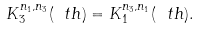Convert formula to latex. <formula><loc_0><loc_0><loc_500><loc_500>K _ { 3 } ^ { n _ { 1 } , n _ { 3 } } ( \ t h ) = K _ { 1 } ^ { n _ { 3 } , n _ { 1 } } ( \ t h ) .</formula> 